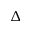<formula> <loc_0><loc_0><loc_500><loc_500>\Delta</formula> 